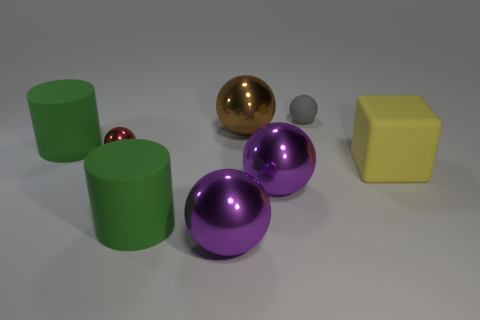Subtract all big spheres. How many spheres are left? 2 Subtract 1 balls. How many balls are left? 4 Subtract all blue cylinders. How many purple spheres are left? 2 Add 2 yellow objects. How many objects exist? 10 Subtract all gray spheres. How many spheres are left? 4 Subtract all balls. How many objects are left? 3 Add 4 purple things. How many purple things are left? 6 Add 7 big metal things. How many big metal things exist? 10 Subtract 0 gray cylinders. How many objects are left? 8 Subtract all cyan balls. Subtract all blue cylinders. How many balls are left? 5 